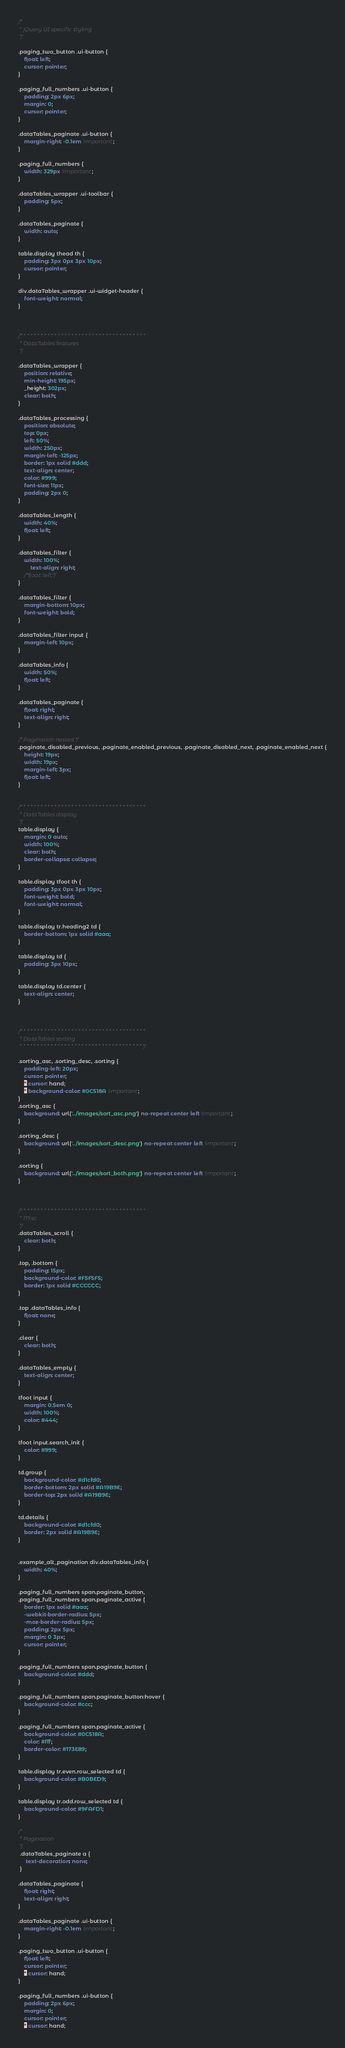Convert code to text. <code><loc_0><loc_0><loc_500><loc_500><_CSS_>/*
 * jQuery UI specific styling
 */

.paging_two_button .ui-button {
	float: left;
	cursor: pointer;
}

.paging_full_numbers .ui-button {
	padding: 2px 6px;
	margin: 0;
	cursor: pointer;
}

.dataTables_paginate .ui-button {
	margin-right: -0.1em !important;
}

.paging_full_numbers {
	width: 329px !important;
}

.dataTables_wrapper .ui-toolbar {
	padding: 5px;
}

.dataTables_paginate {
	width: auto;
}

table.display thead th {
	padding: 3px 0px 3px 10px;
	cursor: pointer;
}

div.dataTables_wrapper .ui-widget-header {
	font-weight: normal;
}



/* * * * * * * * * * * * * * * * * * * * * * * * * * * * * * * * * * * * *
 * DataTables features
 */

.dataTables_wrapper {
	position: relative;
	min-height: 195px;
	_height: 302px;
	clear: both;
}

.dataTables_processing {
	position: absolute;
	top: 0px;
	left: 50%;
	width: 250px;
	margin-left: -125px;
	border: 1px solid #ddd;
	text-align: center;
	color: #999;
	font-size: 11px;
	padding: 2px 0;
}

.dataTables_length {
	width: 40%;
	float: left;
}

.dataTables_filter {
	width: 100%;
        text-align: right;
	/*float: left;*/
}

.dataTables_filter {
	margin-bottom: 10px;
	font-weight: bold;
}

.dataTables_filter input {
	margin-left: 10px;
}

.dataTables_info {
	width: 50%;
	float: left;
}

.dataTables_paginate {
	float: right;
	text-align: right;
}

/* Pagination nested */
.paginate_disabled_previous, .paginate_enabled_previous, .paginate_disabled_next, .paginate_enabled_next {
	height: 19px;
	width: 19px;
	margin-left: 3px;
	float: left;
}


/* * * * * * * * * * * * * * * * * * * * * * * * * * * * * * * * * * * * *
 * DataTables display
 */
table.display {
	margin: 0 auto;
	width: 100%;
	clear: both;
	border-collapse: collapse;
}

table.display tfoot th {
	padding: 3px 0px 3px 10px;
	font-weight: bold;
	font-weight: normal;
}

table.display tr.heading2 td {
	border-bottom: 1px solid #aaa;
}

table.display td {
	padding: 3px 10px;
}

table.display td.center {
	text-align: center;
}



/* * * * * * * * * * * * * * * * * * * * * * * * * * * * * * * * * * * * *
 * DataTables sorting
 * * * * * * * * * * * * * * * * * * * * * * * * * * * * * * * * * * * * */

.sorting_asc, .sorting_desc, .sorting {
	padding-left: 20px;
	cursor: pointer;
	* cursor: hand;
	* background-color: #0C518A !important;
}
.sorting_asc {
	background: url('../images/sort_asc.png') no-repeat center left !important; 
}

.sorting_desc {
	background: url('../images/sort_desc.png') no-repeat center left !important;
}

.sorting {
	background: url('../images/sort_both.png') no-repeat center left !important;
}



/* * * * * * * * * * * * * * * * * * * * * * * * * * * * * * * * * * * * *
 * Misc
 */
.dataTables_scroll {
	clear: both;
}

.top, .bottom {
	padding: 15px;
	background-color: #F5F5F5;
	border: 1px solid #CCCCCC;
}

.top .dataTables_info {
	float: none;
}

.clear {
	clear: both;
}

.dataTables_empty {
	text-align: center;
}

tfoot input {
	margin: 0.5em 0;
	width: 100%;
	color: #444;
}

tfoot input.search_init {
	color: #999;
}

td.group {
	background-color: #d1cfd0;
	border-bottom: 2px solid #A19B9E;
	border-top: 2px solid #A19B9E;
}

td.details {
	background-color: #d1cfd0;
	border: 2px solid #A19B9E;
}


.example_alt_pagination div.dataTables_info {
	width: 40%;
}

.paging_full_numbers span.paginate_button,
.paging_full_numbers span.paginate_active {
	border: 1px solid #aaa;
	-webkit-border-radius: 5px;
	-moz-border-radius: 5px;
	padding: 2px 5px;
	margin: 0 3px;
	cursor: pointer;
}

.paging_full_numbers span.paginate_button {
	background-color: #ddd;
}

.paging_full_numbers span.paginate_button:hover {
	background-color: #ccc;
}

.paging_full_numbers span.paginate_active {
	background-color: #0C518A;
	color: #fff;
	border-color: #173E89;
}

table.display tr.even.row_selected td {
	background-color: #B0BED9;
}

table.display tr.odd.row_selected td {
	background-color: #9FAFD1;
}

/*
 * Pagination
 */
 .dataTables_paginate a {
	 text-decoration: none;
 }
 
.dataTables_paginate {
	float: right;
	text-align: right;
}

.dataTables_paginate .ui-button {
	margin-right: -0.1em !important;
}

.paging_two_button .ui-button {
	float: left;
	cursor: pointer;
	* cursor: hand;
}

.paging_full_numbers .ui-button {
	padding: 2px 6px;
	margin: 0;
	cursor: pointer;
	* cursor: hand;</code> 